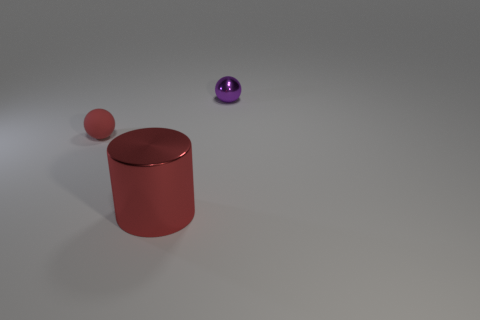Is there any other thing that is the same material as the big red object?
Your response must be concise. Yes. Is the number of purple shiny spheres less than the number of cyan spheres?
Offer a terse response. No. There is a tiny object that is on the left side of the big object; are there any shiny balls left of it?
Keep it short and to the point. No. Is there a small matte sphere behind the small sphere right of the red object behind the big thing?
Offer a terse response. No. Does the tiny thing that is to the left of the purple metallic ball have the same shape as the metal thing that is in front of the shiny sphere?
Keep it short and to the point. No. What is the color of the object that is the same material as the large red cylinder?
Ensure brevity in your answer.  Purple. Are there fewer objects that are in front of the large red metallic cylinder than small balls?
Provide a succinct answer. Yes. What size is the metallic object behind the metallic object in front of the sphere that is on the left side of the small purple object?
Provide a succinct answer. Small. Do the tiny ball to the left of the cylinder and the tiny purple thing have the same material?
Give a very brief answer. No. What is the material of the small ball that is the same color as the cylinder?
Your answer should be compact. Rubber. 